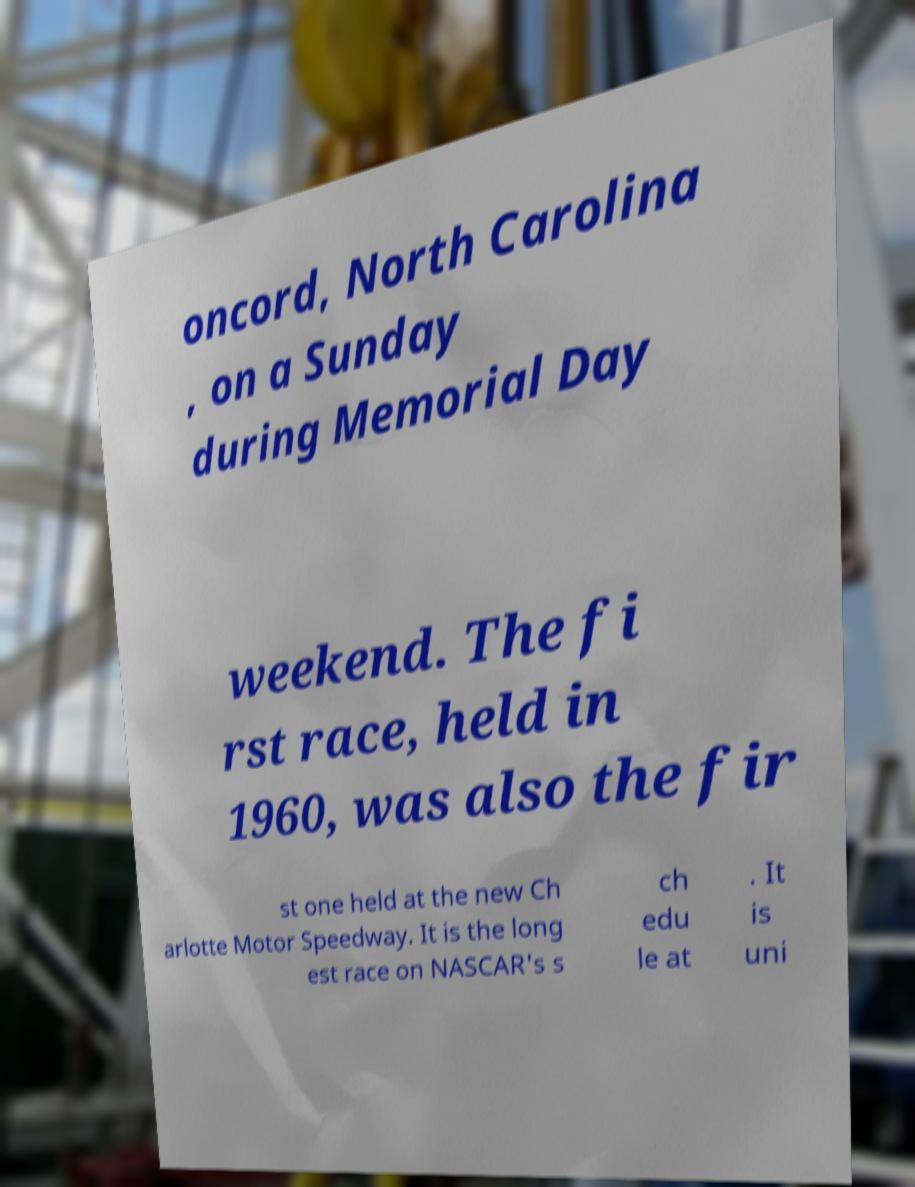For documentation purposes, I need the text within this image transcribed. Could you provide that? oncord, North Carolina , on a Sunday during Memorial Day weekend. The fi rst race, held in 1960, was also the fir st one held at the new Ch arlotte Motor Speedway. It is the long est race on NASCAR's s ch edu le at . It is uni 